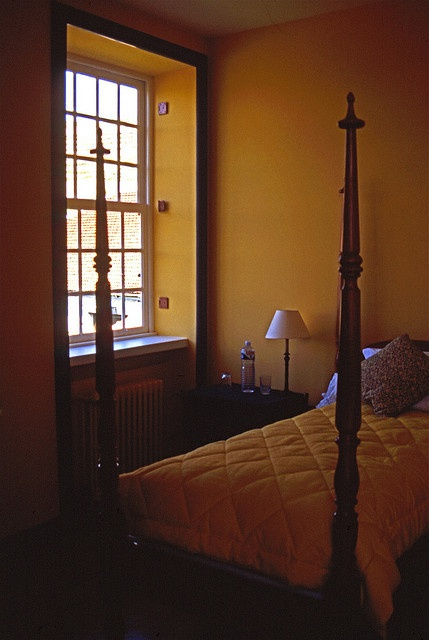Describe the objects in this image and their specific colors. I can see bed in black, maroon, and brown tones, bottle in black, maroon, gray, and purple tones, cup in black, maroon, and gray tones, and cup in black, maroon, purple, and gray tones in this image. 